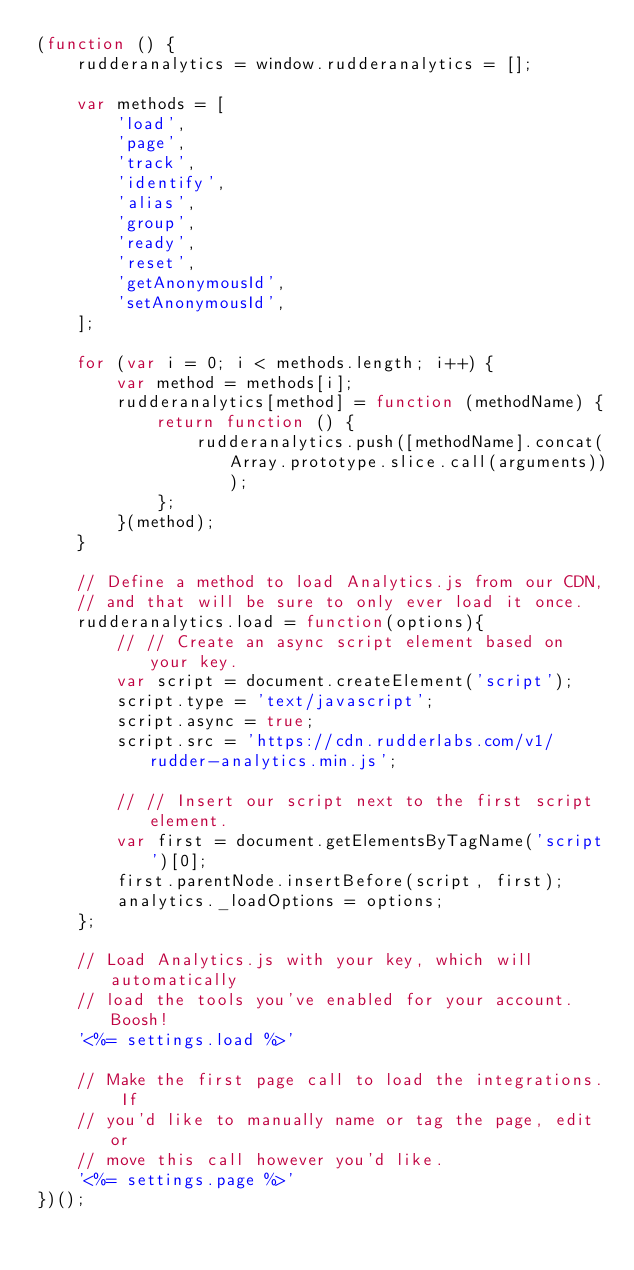Convert code to text. <code><loc_0><loc_0><loc_500><loc_500><_JavaScript_>(function () {
	rudderanalytics = window.rudderanalytics = [];

	var methods = [
		'load',
		'page',
		'track',
		'identify',
		'alias',
		'group',
		'ready',
		'reset',
		'getAnonymousId',
		'setAnonymousId',
	];

	for (var i = 0; i < methods.length; i++) {
		var method = methods[i];
		rudderanalytics[method] = function (methodName) {
			return function () {
				rudderanalytics.push([methodName].concat(Array.prototype.slice.call(arguments)));
			};
		}(method);
	}

	// Define a method to load Analytics.js from our CDN,
	// and that will be sure to only ever load it once.
	rudderanalytics.load = function(options){
		// // Create an async script element based on your key.
		var script = document.createElement('script');
		script.type = 'text/javascript';
		script.async = true;
		script.src = 'https://cdn.rudderlabs.com/v1/rudder-analytics.min.js';

		// // Insert our script next to the first script element.
		var first = document.getElementsByTagName('script')[0];
		first.parentNode.insertBefore(script, first);
		analytics._loadOptions = options;
	};

	// Load Analytics.js with your key, which will automatically
	// load the tools you've enabled for your account. Boosh!
	'<%= settings.load %>'

	// Make the first page call to load the integrations. If
	// you'd like to manually name or tag the page, edit or
	// move this call however you'd like.
	'<%= settings.page %>'
})();
</code> 